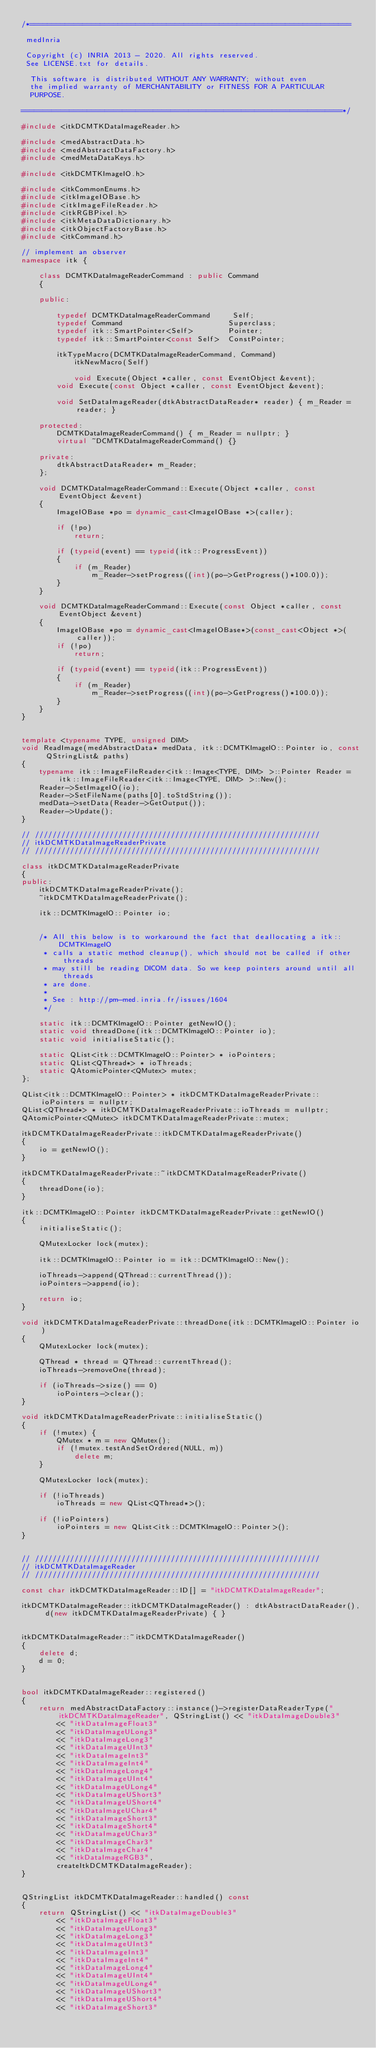<code> <loc_0><loc_0><loc_500><loc_500><_C++_>/*=========================================================================

 medInria

 Copyright (c) INRIA 2013 - 2020. All rights reserved.
 See LICENSE.txt for details.

  This software is distributed WITHOUT ANY WARRANTY; without even
  the implied warranty of MERCHANTABILITY or FITNESS FOR A PARTICULAR
  PURPOSE.

=========================================================================*/

#include <itkDCMTKDataImageReader.h>

#include <medAbstractData.h>
#include <medAbstractDataFactory.h>
#include <medMetaDataKeys.h>

#include <itkDCMTKImageIO.h>

#include <itkCommonEnums.h>
#include <itkImageIOBase.h>
#include <itkImageFileReader.h>
#include <itkRGBPixel.h>
#include <itkMetaDataDictionary.h>
#include <itkObjectFactoryBase.h>
#include <itkCommand.h>

// implement an observer
namespace itk {

    class DCMTKDataImageReaderCommand : public Command
    {

    public:

        typedef DCMTKDataImageReaderCommand     Self;
        typedef Command                        Superclass;
        typedef itk::SmartPointer<Self>        Pointer;
        typedef itk::SmartPointer<const Self>  ConstPointer;

        itkTypeMacro(DCMTKDataImageReaderCommand, Command)
            itkNewMacro(Self)

            void Execute(Object *caller, const EventObject &event);
        void Execute(const Object *caller, const EventObject &event);

        void SetDataImageReader(dtkAbstractDataReader* reader) { m_Reader = reader; }

    protected:
        DCMTKDataImageReaderCommand() { m_Reader = nullptr; }
        virtual ~DCMTKDataImageReaderCommand() {}

    private:
        dtkAbstractDataReader* m_Reader;
    };

    void DCMTKDataImageReaderCommand::Execute(Object *caller, const EventObject &event)
    {
        ImageIOBase *po = dynamic_cast<ImageIOBase *>(caller);

        if (!po)
            return;

        if (typeid(event) == typeid(itk::ProgressEvent))
        {
            if (m_Reader)
                m_Reader->setProgress((int)(po->GetProgress()*100.0));
        }
    }

    void DCMTKDataImageReaderCommand::Execute(const Object *caller, const EventObject &event)
    {
        ImageIOBase *po = dynamic_cast<ImageIOBase*>(const_cast<Object *>(caller));
        if (!po)
            return;

        if (typeid(event) == typeid(itk::ProgressEvent))
        {
            if (m_Reader)
                m_Reader->setProgress((int)(po->GetProgress()*100.0));
        }
    }
}


template <typename TYPE, unsigned DIM>
void ReadImage(medAbstractData* medData, itk::DCMTKImageIO::Pointer io, const QStringList& paths)
{
    typename itk::ImageFileReader<itk::Image<TYPE, DIM> >::Pointer Reader = itk::ImageFileReader<itk::Image<TYPE, DIM> >::New();
    Reader->SetImageIO(io);
    Reader->SetFileName(paths[0].toStdString());
    medData->setData(Reader->GetOutput());
    Reader->Update();
}

// /////////////////////////////////////////////////////////////////
// itkDCMTKDataImageReaderPrivate
// /////////////////////////////////////////////////////////////////

class itkDCMTKDataImageReaderPrivate
{
public:
    itkDCMTKDataImageReaderPrivate();
    ~itkDCMTKDataImageReaderPrivate();

    itk::DCMTKImageIO::Pointer io;


    /* All this below is to workaround the fact that deallocating a itk::DCMTKImageIO
     * calls a static method cleanup(), which should not be called if other threads
     * may still be reading DICOM data. So we keep pointers around until all threads
     * are done.
     *
     * See : http://pm-med.inria.fr/issues/1604
     */

    static itk::DCMTKImageIO::Pointer getNewIO();
    static void threadDone(itk::DCMTKImageIO::Pointer io);
    static void initialiseStatic();

    static QList<itk::DCMTKImageIO::Pointer> * ioPointers;
    static QList<QThread*> * ioThreads;
    static QAtomicPointer<QMutex> mutex;
};

QList<itk::DCMTKImageIO::Pointer> * itkDCMTKDataImageReaderPrivate::ioPointers = nullptr;
QList<QThread*> * itkDCMTKDataImageReaderPrivate::ioThreads = nullptr;
QAtomicPointer<QMutex> itkDCMTKDataImageReaderPrivate::mutex;

itkDCMTKDataImageReaderPrivate::itkDCMTKDataImageReaderPrivate()
{
    io = getNewIO();
}

itkDCMTKDataImageReaderPrivate::~itkDCMTKDataImageReaderPrivate()
{
    threadDone(io);
}

itk::DCMTKImageIO::Pointer itkDCMTKDataImageReaderPrivate::getNewIO()
{
    initialiseStatic();

    QMutexLocker lock(mutex);

    itk::DCMTKImageIO::Pointer io = itk::DCMTKImageIO::New();

    ioThreads->append(QThread::currentThread());
    ioPointers->append(io);

    return io;
}

void itkDCMTKDataImageReaderPrivate::threadDone(itk::DCMTKImageIO::Pointer io)
{
    QMutexLocker lock(mutex);

    QThread * thread = QThread::currentThread();
    ioThreads->removeOne(thread);

    if (ioThreads->size() == 0)
        ioPointers->clear();
}

void itkDCMTKDataImageReaderPrivate::initialiseStatic()
{
    if (!mutex) {
        QMutex * m = new QMutex();
        if (!mutex.testAndSetOrdered(NULL, m))
            delete m;
    }

    QMutexLocker lock(mutex);

    if (!ioThreads)
        ioThreads = new QList<QThread*>();

    if (!ioPointers)
        ioPointers = new QList<itk::DCMTKImageIO::Pointer>();
}


// /////////////////////////////////////////////////////////////////
// itkDCMTKDataImageReader
// /////////////////////////////////////////////////////////////////

const char itkDCMTKDataImageReader::ID[] = "itkDCMTKDataImageReader";

itkDCMTKDataImageReader::itkDCMTKDataImageReader() : dtkAbstractDataReader(), d(new itkDCMTKDataImageReaderPrivate) { }


itkDCMTKDataImageReader::~itkDCMTKDataImageReader()
{
    delete d;
    d = 0;
}


bool itkDCMTKDataImageReader::registered()
{
    return medAbstractDataFactory::instance()->registerDataReaderType("itkDCMTKDataImageReader", QStringList() << "itkDataImageDouble3"
        << "itkDataImageFloat3"
        << "itkDataImageULong3"
        << "itkDataImageLong3"
        << "itkDataImageUInt3"
        << "itkDataImageInt3"
        << "itkDataImageInt4"
        << "itkDataImageLong4"
        << "itkDataImageUInt4"
        << "itkDataImageULong4"
        << "itkDataImageUShort3"
        << "itkDataImageUShort4"
        << "itkDataImageUChar4"
        << "itkDataImageShort3"
        << "itkDataImageShort4"
        << "itkDataImageUChar3"
        << "itkDataImageChar3"
        << "itkDataImageChar4"
        << "itkDataImageRGB3",
        createItkDCMTKDataImageReader);
}


QStringList itkDCMTKDataImageReader::handled() const
{
    return QStringList() << "itkDataImageDouble3"
        << "itkDataImageFloat3"
        << "itkDataImageULong3"
        << "itkDataImageLong3"
        << "itkDataImageUInt3"
        << "itkDataImageInt3"
        << "itkDataImageInt4"
        << "itkDataImageLong4"
        << "itkDataImageUInt4"
        << "itkDataImageULong4"
        << "itkDataImageUShort3"
        << "itkDataImageUShort4"
        << "itkDataImageShort3"</code> 